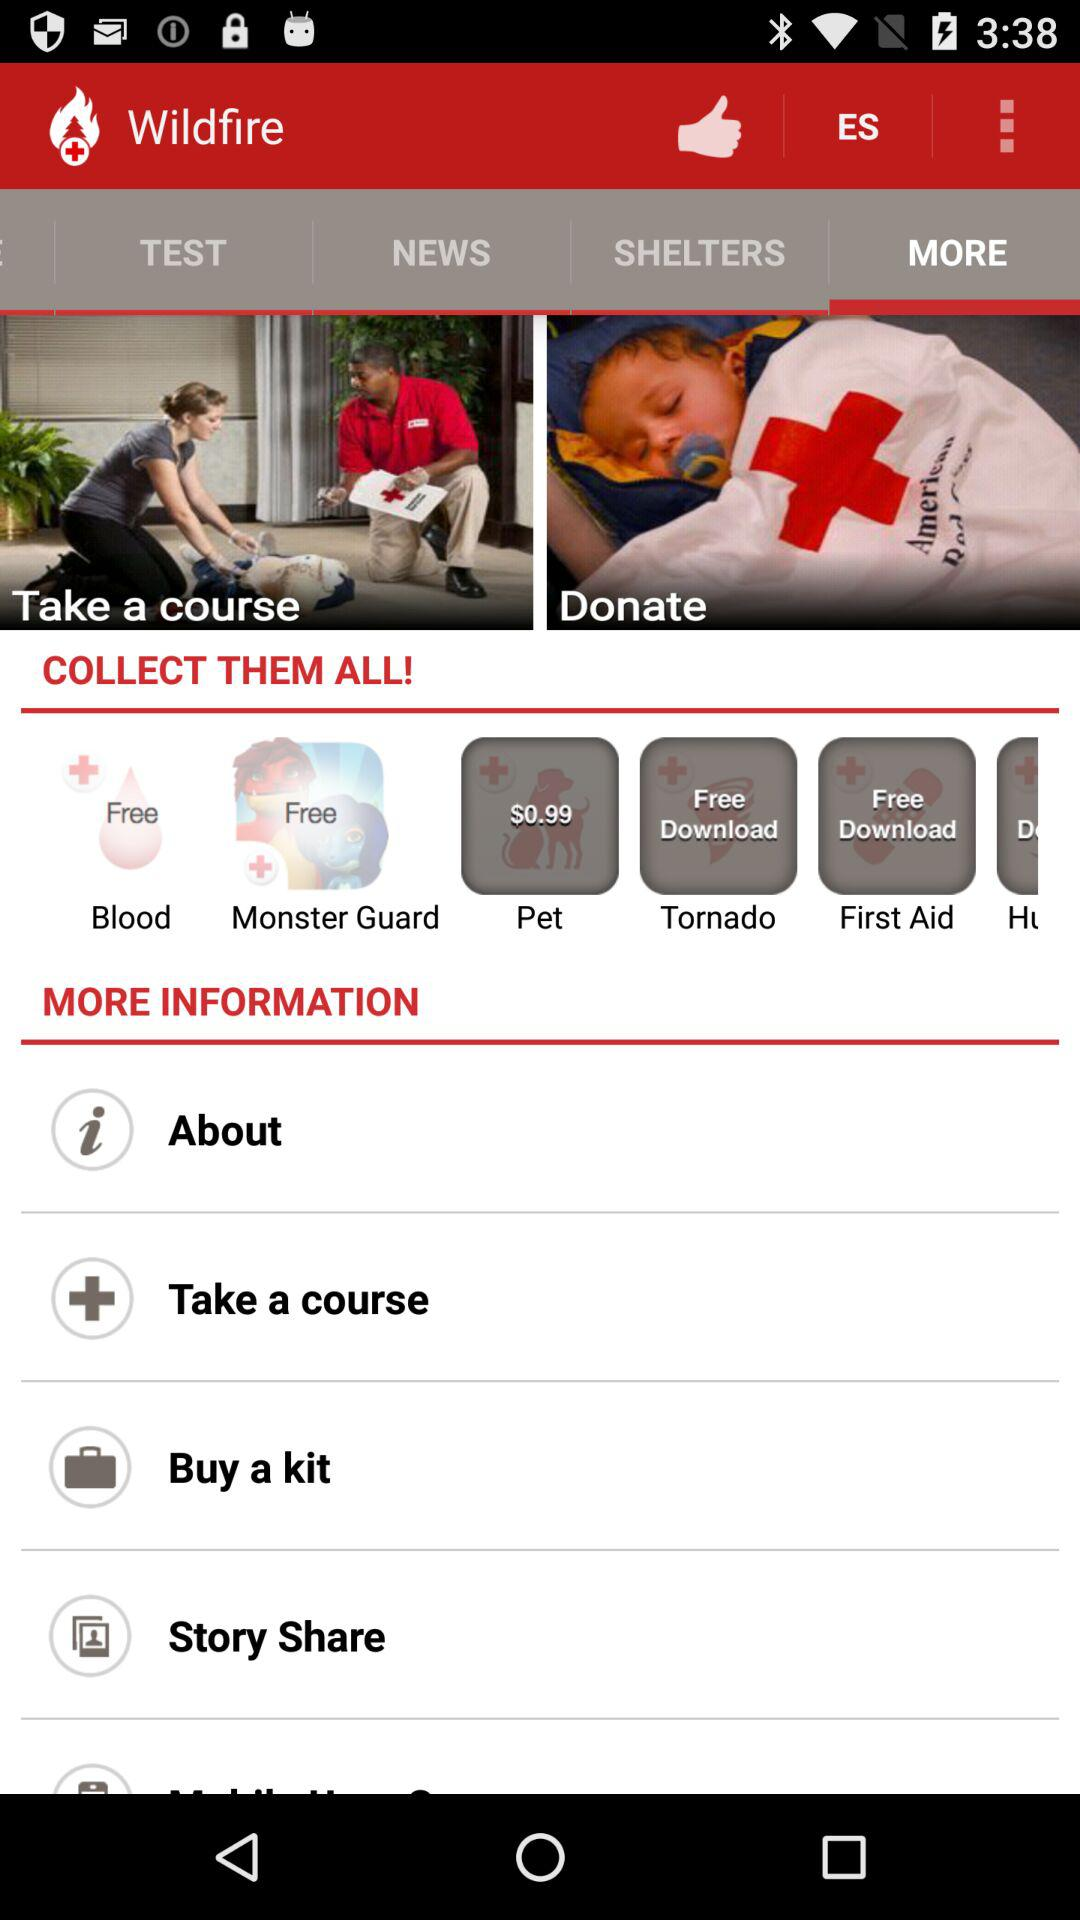What is the name of application? The name of the application is Wildfire. 